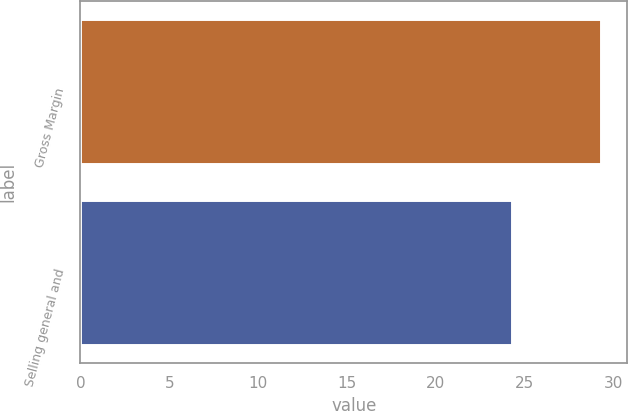Convert chart. <chart><loc_0><loc_0><loc_500><loc_500><bar_chart><fcel>Gross Margin<fcel>Selling general and<nl><fcel>29.3<fcel>24.3<nl></chart> 